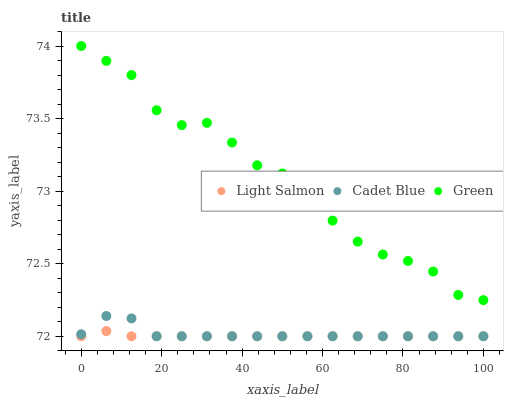Does Light Salmon have the minimum area under the curve?
Answer yes or no. Yes. Does Green have the maximum area under the curve?
Answer yes or no. Yes. Does Cadet Blue have the minimum area under the curve?
Answer yes or no. No. Does Cadet Blue have the maximum area under the curve?
Answer yes or no. No. Is Light Salmon the smoothest?
Answer yes or no. Yes. Is Green the roughest?
Answer yes or no. Yes. Is Cadet Blue the smoothest?
Answer yes or no. No. Is Cadet Blue the roughest?
Answer yes or no. No. Does Light Salmon have the lowest value?
Answer yes or no. Yes. Does Green have the lowest value?
Answer yes or no. No. Does Green have the highest value?
Answer yes or no. Yes. Does Cadet Blue have the highest value?
Answer yes or no. No. Is Light Salmon less than Green?
Answer yes or no. Yes. Is Green greater than Cadet Blue?
Answer yes or no. Yes. Does Light Salmon intersect Cadet Blue?
Answer yes or no. Yes. Is Light Salmon less than Cadet Blue?
Answer yes or no. No. Is Light Salmon greater than Cadet Blue?
Answer yes or no. No. Does Light Salmon intersect Green?
Answer yes or no. No. 